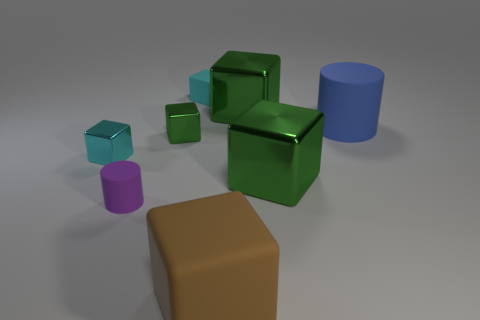Is the shape of the big blue object the same as the matte object behind the big rubber cylinder?
Provide a succinct answer. No. What material is the cylinder on the right side of the big rubber thing in front of the blue matte cylinder?
Provide a short and direct response. Rubber. Is the number of tiny matte cubes in front of the cyan rubber block the same as the number of large cyan metallic objects?
Provide a short and direct response. Yes. Is there any other thing that has the same material as the brown thing?
Ensure brevity in your answer.  Yes. There is a matte cylinder behind the small cylinder; is it the same color as the small matte thing in front of the small cyan matte block?
Make the answer very short. No. How many tiny cubes are left of the tiny cyan rubber object and behind the small green metal cube?
Your answer should be compact. 0. How many other things are there of the same shape as the brown rubber thing?
Your response must be concise. 5. Are there more tiny green shiny blocks that are in front of the big brown block than large cyan balls?
Your response must be concise. No. There is a big object that is behind the large blue cylinder; what color is it?
Your response must be concise. Green. The object that is the same color as the small matte block is what size?
Provide a short and direct response. Small. 